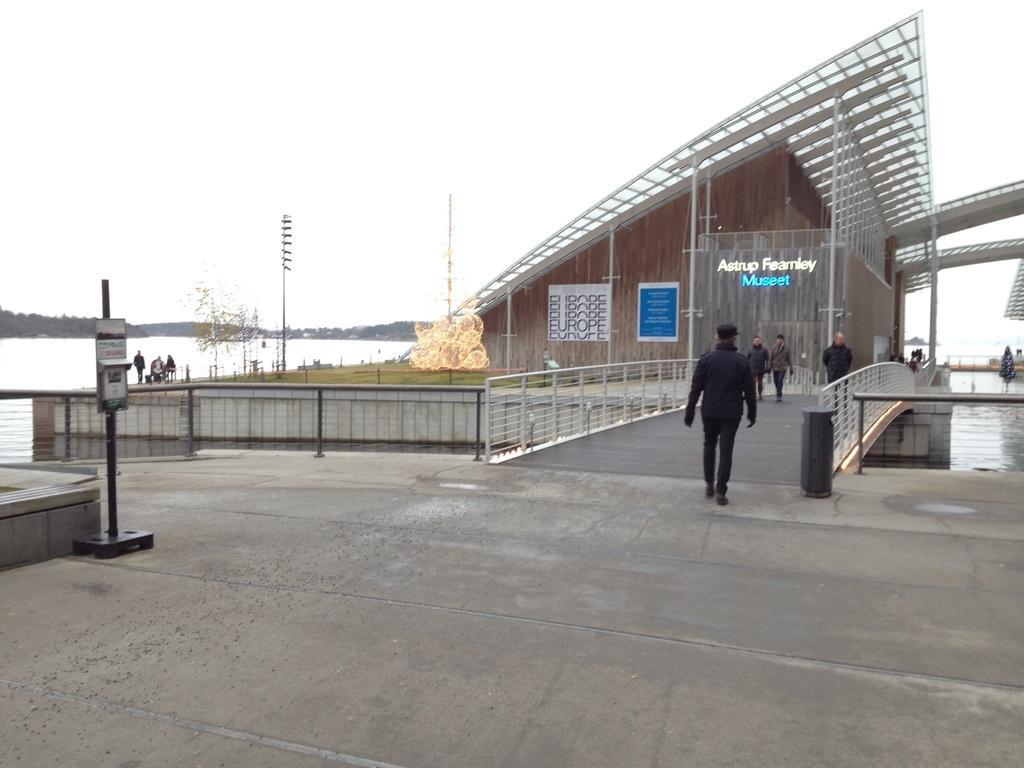Describe this image in one or two sentences. In this image there is a building in the middle. In front of the building there is a bridge on which there are few people walking. Under the bridge there is water. At the top there is the sky. On the left side there is a pole to which there is a board. There is a fence around the bridge. Beside the building there is a ground on which there are poles and some lights. On the right side there is a pole. 